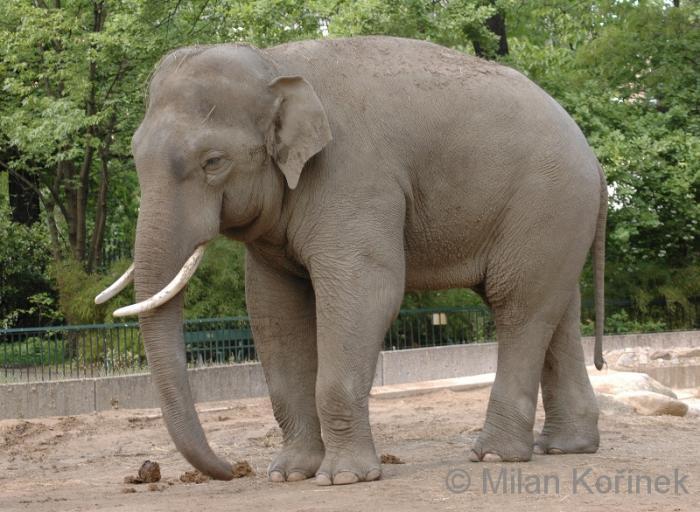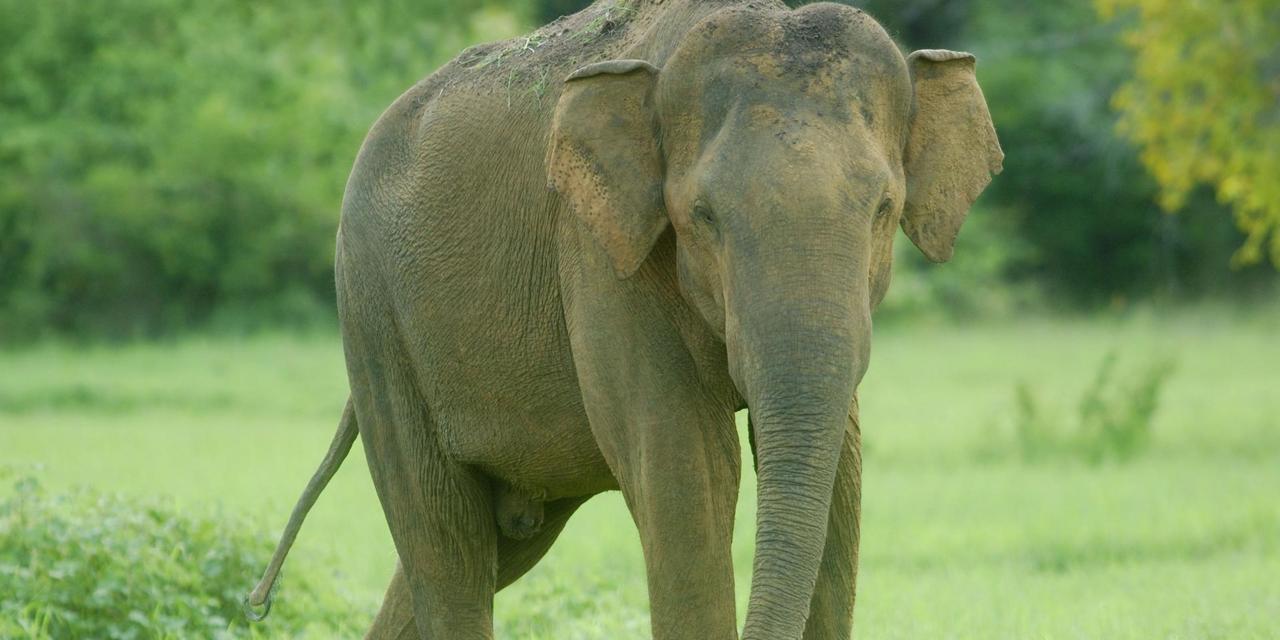The first image is the image on the left, the second image is the image on the right. For the images displayed, is the sentence "An elephant is in profile facing the right." factually correct? Answer yes or no. No. The first image is the image on the left, the second image is the image on the right. Examine the images to the left and right. Is the description "Each picture has only one elephant in it." accurate? Answer yes or no. Yes. 